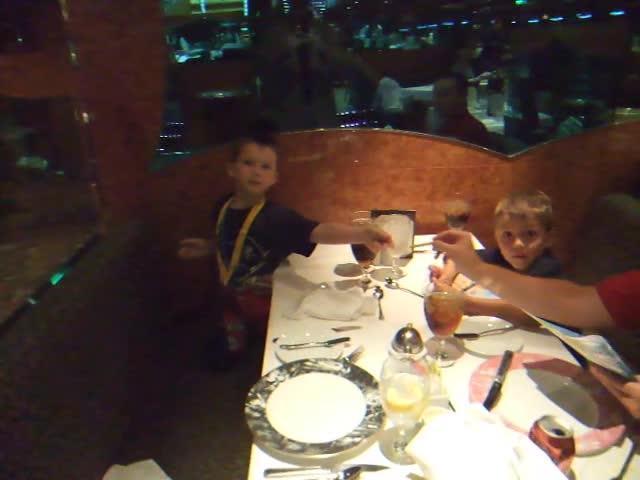What color is the lanyard string worn around the little boy's neck?
Select the accurate answer and provide explanation: 'Answer: answer
Rationale: rationale.'
Options: Yellow, green, blue, black. Answer: yellow.
Rationale: The lanyard around the boy's neck is light and bright in color. it is yellow. 